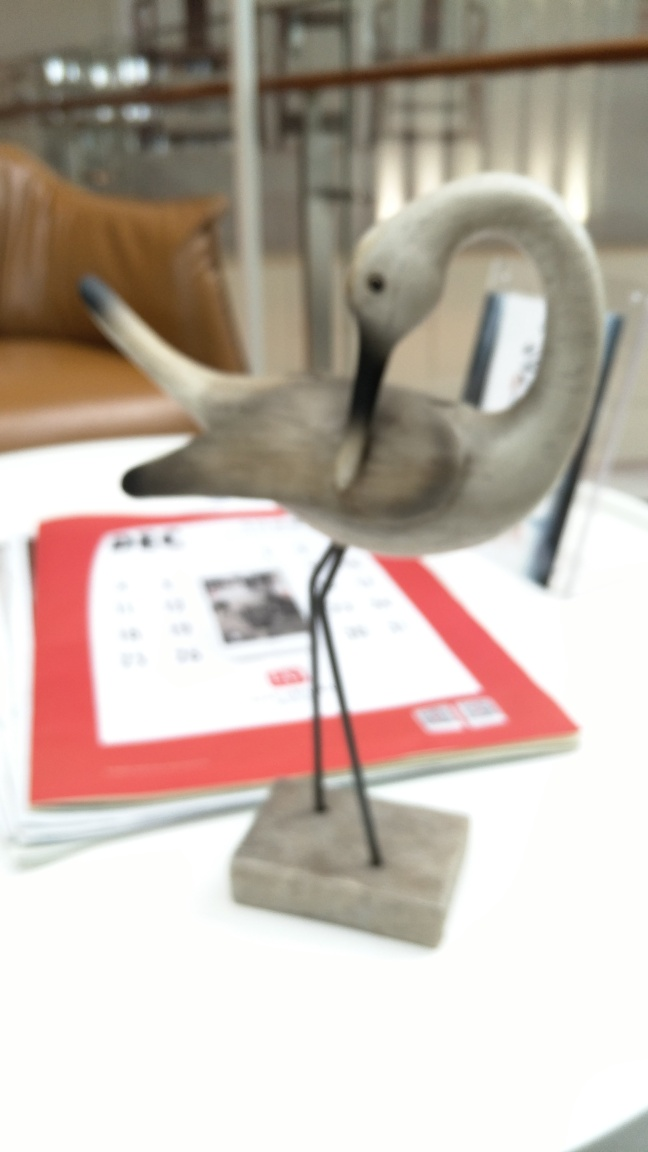Is the main subject, a crane, blurry?
A. No
B. Yes
Answer with the option's letter from the given choices directly.
 B. 